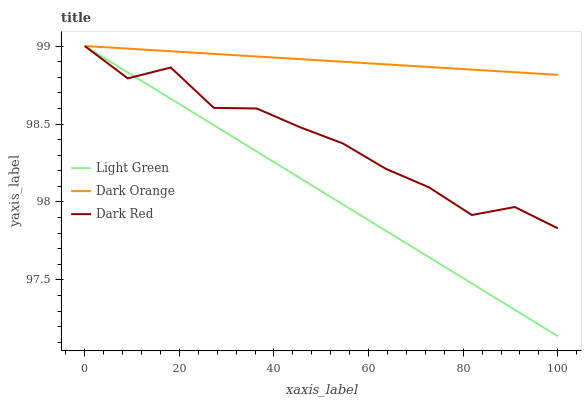Does Dark Red have the minimum area under the curve?
Answer yes or no. No. Does Dark Red have the maximum area under the curve?
Answer yes or no. No. Is Dark Red the smoothest?
Answer yes or no. No. Is Light Green the roughest?
Answer yes or no. No. Does Dark Red have the lowest value?
Answer yes or no. No. 